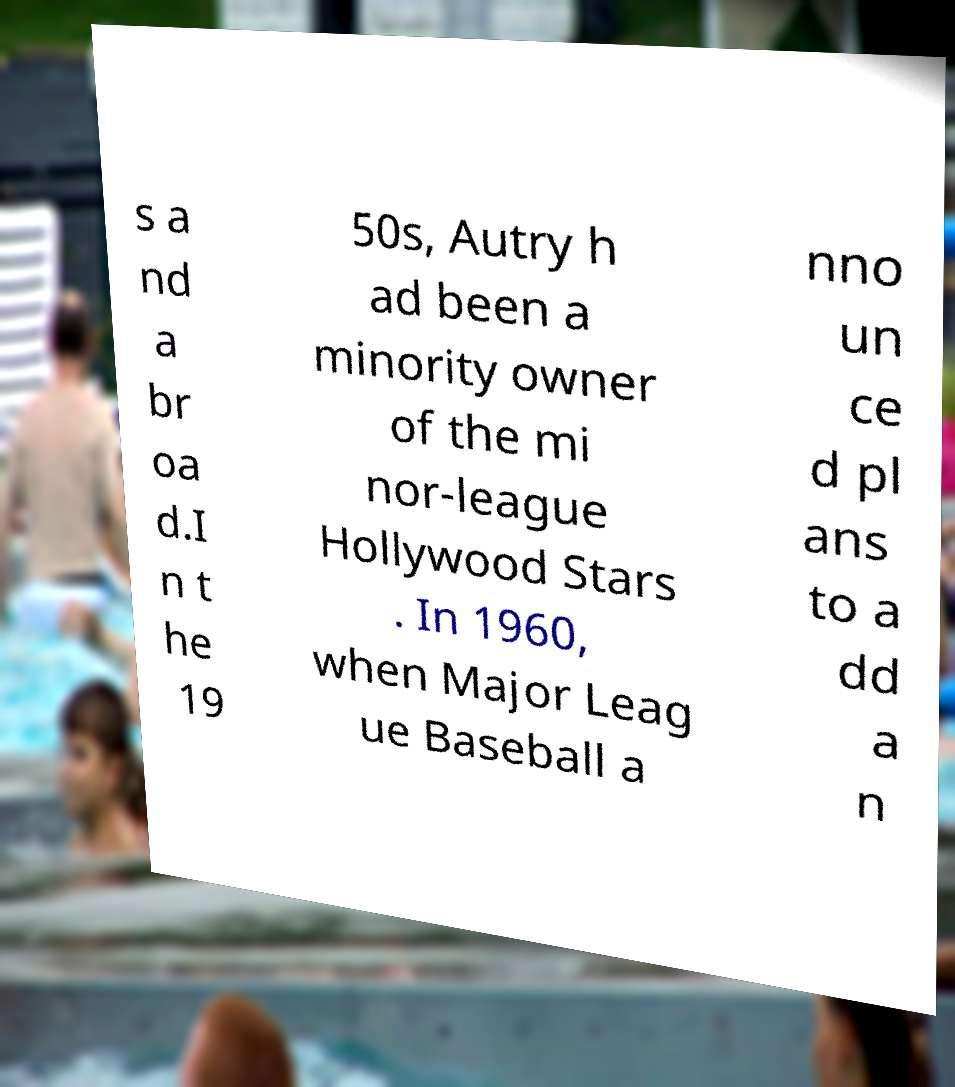What messages or text are displayed in this image? I need them in a readable, typed format. s a nd a br oa d.I n t he 19 50s, Autry h ad been a minority owner of the mi nor-league Hollywood Stars . In 1960, when Major Leag ue Baseball a nno un ce d pl ans to a dd a n 